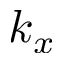<formula> <loc_0><loc_0><loc_500><loc_500>k _ { x }</formula> 